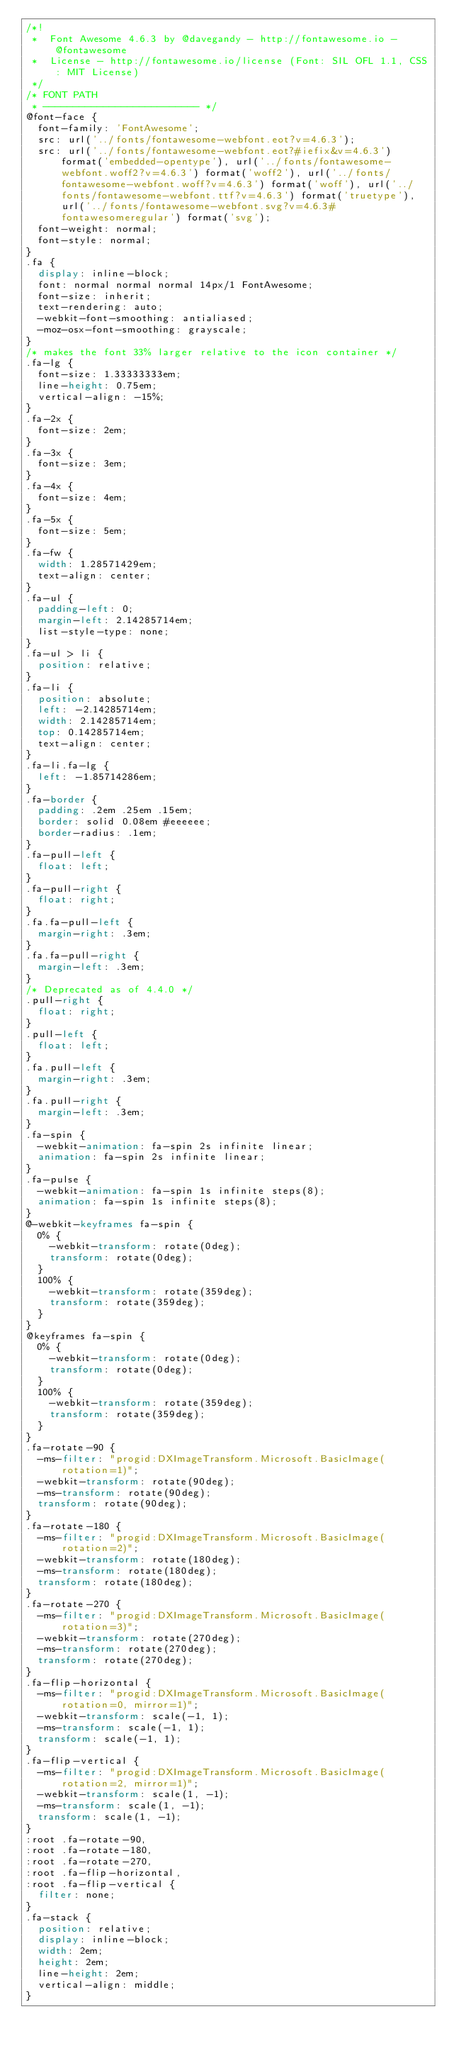<code> <loc_0><loc_0><loc_500><loc_500><_CSS_>/*!
 *  Font Awesome 4.6.3 by @davegandy - http://fontawesome.io - @fontawesome
 *  License - http://fontawesome.io/license (Font: SIL OFL 1.1, CSS: MIT License)
 */
/* FONT PATH
 * -------------------------- */
@font-face {
  font-family: 'FontAwesome';
  src: url('../fonts/fontawesome-webfont.eot?v=4.6.3');
  src: url('../fonts/fontawesome-webfont.eot?#iefix&v=4.6.3') format('embedded-opentype'), url('../fonts/fontawesome-webfont.woff2?v=4.6.3') format('woff2'), url('../fonts/fontawesome-webfont.woff?v=4.6.3') format('woff'), url('../fonts/fontawesome-webfont.ttf?v=4.6.3') format('truetype'), url('../fonts/fontawesome-webfont.svg?v=4.6.3#fontawesomeregular') format('svg');
  font-weight: normal;
  font-style: normal;
}
.fa {
  display: inline-block;
  font: normal normal normal 14px/1 FontAwesome;
  font-size: inherit;
  text-rendering: auto;
  -webkit-font-smoothing: antialiased;
  -moz-osx-font-smoothing: grayscale;
}
/* makes the font 33% larger relative to the icon container */
.fa-lg {
  font-size: 1.33333333em;
  line-height: 0.75em;
  vertical-align: -15%;
}
.fa-2x {
  font-size: 2em;
}
.fa-3x {
  font-size: 3em;
}
.fa-4x {
  font-size: 4em;
}
.fa-5x {
  font-size: 5em;
}
.fa-fw {
  width: 1.28571429em;
  text-align: center;
}
.fa-ul {
  padding-left: 0;
  margin-left: 2.14285714em;
  list-style-type: none;
}
.fa-ul > li {
  position: relative;
}
.fa-li {
  position: absolute;
  left: -2.14285714em;
  width: 2.14285714em;
  top: 0.14285714em;
  text-align: center;
}
.fa-li.fa-lg {
  left: -1.85714286em;
}
.fa-border {
  padding: .2em .25em .15em;
  border: solid 0.08em #eeeeee;
  border-radius: .1em;
}
.fa-pull-left {
  float: left;
}
.fa-pull-right {
  float: right;
}
.fa.fa-pull-left {
  margin-right: .3em;
}
.fa.fa-pull-right {
  margin-left: .3em;
}
/* Deprecated as of 4.4.0 */
.pull-right {
  float: right;
}
.pull-left {
  float: left;
}
.fa.pull-left {
  margin-right: .3em;
}
.fa.pull-right {
  margin-left: .3em;
}
.fa-spin {
  -webkit-animation: fa-spin 2s infinite linear;
  animation: fa-spin 2s infinite linear;
}
.fa-pulse {
  -webkit-animation: fa-spin 1s infinite steps(8);
  animation: fa-spin 1s infinite steps(8);
}
@-webkit-keyframes fa-spin {
  0% {
    -webkit-transform: rotate(0deg);
    transform: rotate(0deg);
  }
  100% {
    -webkit-transform: rotate(359deg);
    transform: rotate(359deg);
  }
}
@keyframes fa-spin {
  0% {
    -webkit-transform: rotate(0deg);
    transform: rotate(0deg);
  }
  100% {
    -webkit-transform: rotate(359deg);
    transform: rotate(359deg);
  }
}
.fa-rotate-90 {
  -ms-filter: "progid:DXImageTransform.Microsoft.BasicImage(rotation=1)";
  -webkit-transform: rotate(90deg);
  -ms-transform: rotate(90deg);
  transform: rotate(90deg);
}
.fa-rotate-180 {
  -ms-filter: "progid:DXImageTransform.Microsoft.BasicImage(rotation=2)";
  -webkit-transform: rotate(180deg);
  -ms-transform: rotate(180deg);
  transform: rotate(180deg);
}
.fa-rotate-270 {
  -ms-filter: "progid:DXImageTransform.Microsoft.BasicImage(rotation=3)";
  -webkit-transform: rotate(270deg);
  -ms-transform: rotate(270deg);
  transform: rotate(270deg);
}
.fa-flip-horizontal {
  -ms-filter: "progid:DXImageTransform.Microsoft.BasicImage(rotation=0, mirror=1)";
  -webkit-transform: scale(-1, 1);
  -ms-transform: scale(-1, 1);
  transform: scale(-1, 1);
}
.fa-flip-vertical {
  -ms-filter: "progid:DXImageTransform.Microsoft.BasicImage(rotation=2, mirror=1)";
  -webkit-transform: scale(1, -1);
  -ms-transform: scale(1, -1);
  transform: scale(1, -1);
}
:root .fa-rotate-90,
:root .fa-rotate-180,
:root .fa-rotate-270,
:root .fa-flip-horizontal,
:root .fa-flip-vertical {
  filter: none;
}
.fa-stack {
  position: relative;
  display: inline-block;
  width: 2em;
  height: 2em;
  line-height: 2em;
  vertical-align: middle;
}</code> 